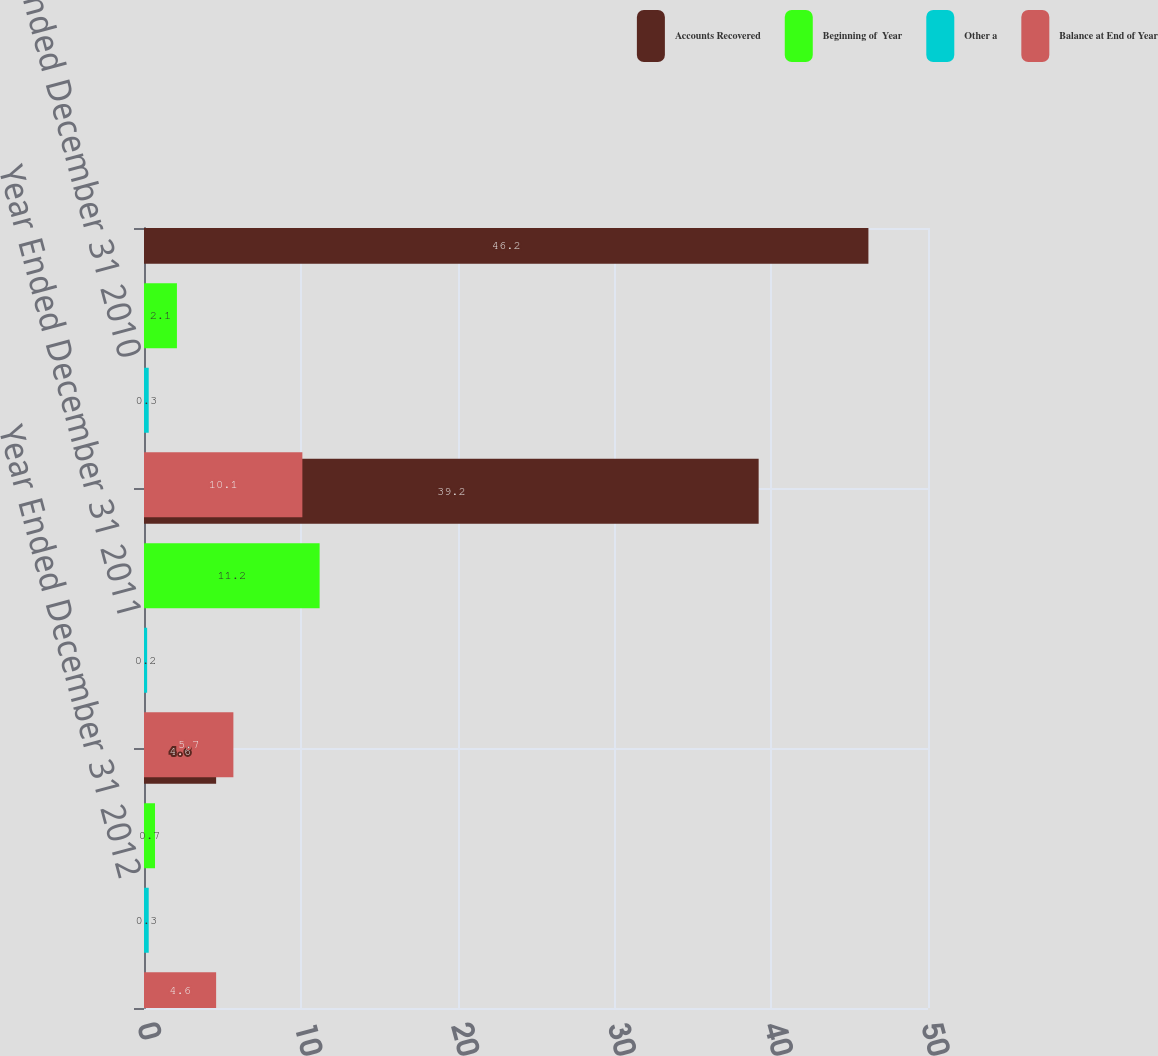Convert chart to OTSL. <chart><loc_0><loc_0><loc_500><loc_500><stacked_bar_chart><ecel><fcel>Year Ended December 31 2012<fcel>Year Ended December 31 2011<fcel>Year Ended December 31 2010<nl><fcel>Accounts Recovered<fcel>4.6<fcel>39.2<fcel>46.2<nl><fcel>Beginning of  Year<fcel>0.7<fcel>11.2<fcel>2.1<nl><fcel>Other a<fcel>0.3<fcel>0.2<fcel>0.3<nl><fcel>Balance at End of Year<fcel>4.6<fcel>5.7<fcel>10.1<nl></chart> 